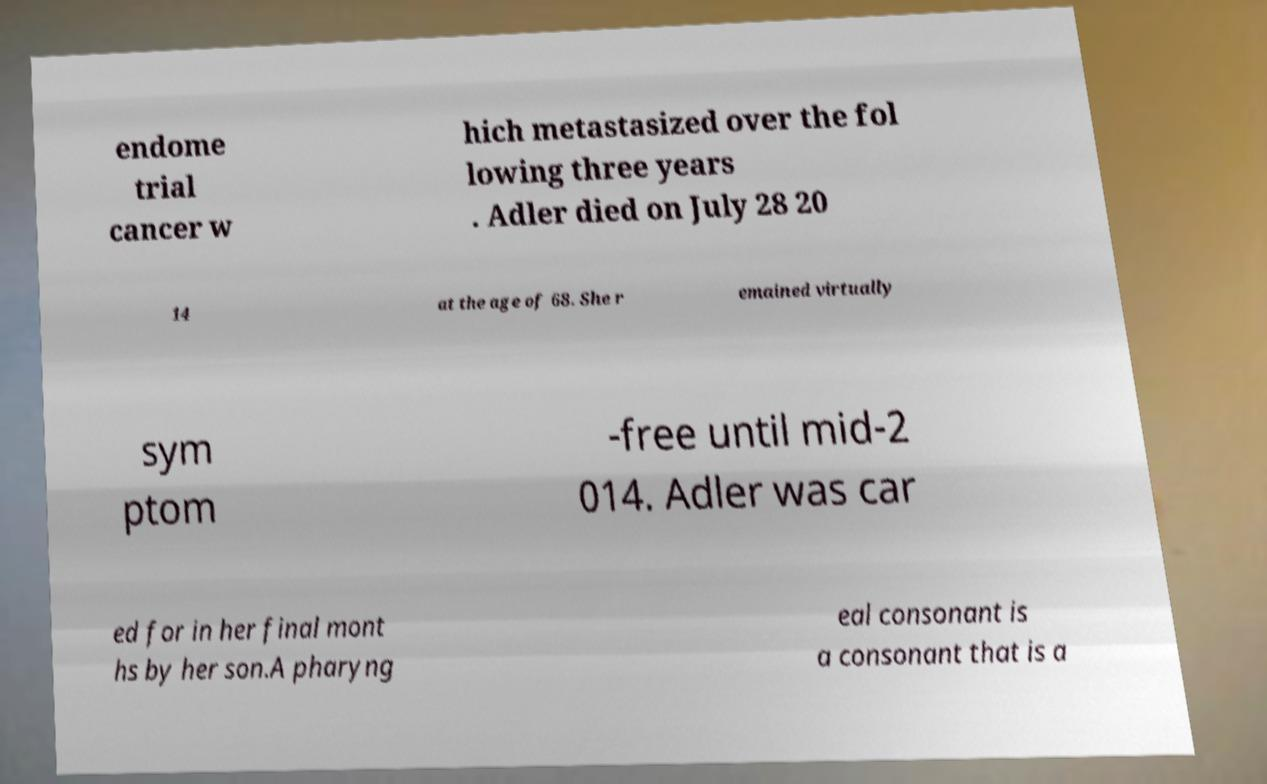Please read and relay the text visible in this image. What does it say? endome trial cancer w hich metastasized over the fol lowing three years . Adler died on July 28 20 14 at the age of 68. She r emained virtually sym ptom -free until mid-2 014. Adler was car ed for in her final mont hs by her son.A pharyng eal consonant is a consonant that is a 